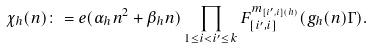Convert formula to latex. <formula><loc_0><loc_0><loc_500><loc_500>\chi _ { h } ( n ) \colon = e ( \alpha _ { h } n ^ { 2 } + \beta _ { h } n ) \prod _ { 1 \leq i < i ^ { \prime } \leq k } F _ { [ i ^ { \prime } , i ] } ^ { m _ { [ i ^ { \prime } , i ] ( h ) } } ( g _ { h } ( n ) \Gamma ) .</formula> 